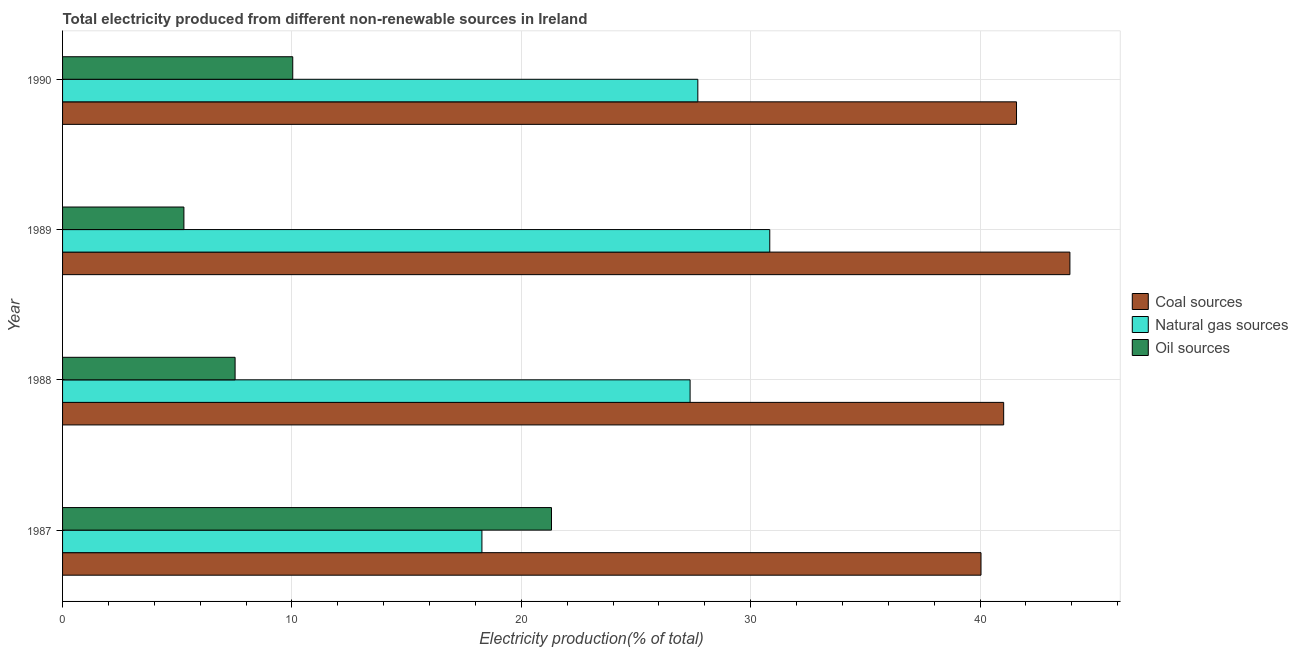How many different coloured bars are there?
Provide a short and direct response. 3. Are the number of bars per tick equal to the number of legend labels?
Your answer should be compact. Yes. How many bars are there on the 4th tick from the top?
Your answer should be very brief. 3. What is the label of the 2nd group of bars from the top?
Your response must be concise. 1989. In how many cases, is the number of bars for a given year not equal to the number of legend labels?
Offer a terse response. 0. What is the percentage of electricity produced by oil sources in 1990?
Your answer should be compact. 10.04. Across all years, what is the maximum percentage of electricity produced by oil sources?
Make the answer very short. 21.32. Across all years, what is the minimum percentage of electricity produced by coal?
Give a very brief answer. 40.04. In which year was the percentage of electricity produced by coal minimum?
Provide a short and direct response. 1987. What is the total percentage of electricity produced by oil sources in the graph?
Provide a succinct answer. 44.16. What is the difference between the percentage of electricity produced by oil sources in 1989 and that in 1990?
Your answer should be compact. -4.75. What is the difference between the percentage of electricity produced by coal in 1988 and the percentage of electricity produced by natural gas in 1987?
Provide a succinct answer. 22.75. What is the average percentage of electricity produced by coal per year?
Ensure brevity in your answer.  41.65. In the year 1988, what is the difference between the percentage of electricity produced by coal and percentage of electricity produced by natural gas?
Your answer should be very brief. 13.67. What is the ratio of the percentage of electricity produced by oil sources in 1987 to that in 1989?
Ensure brevity in your answer.  4.03. What is the difference between the highest and the second highest percentage of electricity produced by oil sources?
Give a very brief answer. 11.28. What is the difference between the highest and the lowest percentage of electricity produced by natural gas?
Offer a terse response. 12.55. In how many years, is the percentage of electricity produced by coal greater than the average percentage of electricity produced by coal taken over all years?
Offer a terse response. 1. What does the 3rd bar from the top in 1989 represents?
Give a very brief answer. Coal sources. What does the 2nd bar from the bottom in 1987 represents?
Your response must be concise. Natural gas sources. Is it the case that in every year, the sum of the percentage of electricity produced by coal and percentage of electricity produced by natural gas is greater than the percentage of electricity produced by oil sources?
Ensure brevity in your answer.  Yes. How many bars are there?
Offer a very short reply. 12. Are all the bars in the graph horizontal?
Keep it short and to the point. Yes. Are the values on the major ticks of X-axis written in scientific E-notation?
Offer a terse response. No. Where does the legend appear in the graph?
Your response must be concise. Center right. How many legend labels are there?
Offer a very short reply. 3. What is the title of the graph?
Keep it short and to the point. Total electricity produced from different non-renewable sources in Ireland. Does "Private sector" appear as one of the legend labels in the graph?
Provide a short and direct response. No. What is the label or title of the Y-axis?
Your response must be concise. Year. What is the Electricity production(% of total) of Coal sources in 1987?
Provide a succinct answer. 40.04. What is the Electricity production(% of total) of Natural gas sources in 1987?
Give a very brief answer. 18.28. What is the Electricity production(% of total) in Oil sources in 1987?
Your answer should be compact. 21.32. What is the Electricity production(% of total) in Coal sources in 1988?
Your answer should be compact. 41.03. What is the Electricity production(% of total) of Natural gas sources in 1988?
Your response must be concise. 27.36. What is the Electricity production(% of total) of Oil sources in 1988?
Provide a short and direct response. 7.52. What is the Electricity production(% of total) of Coal sources in 1989?
Provide a succinct answer. 43.92. What is the Electricity production(% of total) in Natural gas sources in 1989?
Your answer should be very brief. 30.83. What is the Electricity production(% of total) in Oil sources in 1989?
Ensure brevity in your answer.  5.29. What is the Electricity production(% of total) of Coal sources in 1990?
Make the answer very short. 41.59. What is the Electricity production(% of total) in Natural gas sources in 1990?
Offer a very short reply. 27.7. What is the Electricity production(% of total) of Oil sources in 1990?
Ensure brevity in your answer.  10.04. Across all years, what is the maximum Electricity production(% of total) of Coal sources?
Offer a terse response. 43.92. Across all years, what is the maximum Electricity production(% of total) in Natural gas sources?
Offer a terse response. 30.83. Across all years, what is the maximum Electricity production(% of total) of Oil sources?
Your answer should be compact. 21.32. Across all years, what is the minimum Electricity production(% of total) of Coal sources?
Make the answer very short. 40.04. Across all years, what is the minimum Electricity production(% of total) in Natural gas sources?
Ensure brevity in your answer.  18.28. Across all years, what is the minimum Electricity production(% of total) of Oil sources?
Your answer should be compact. 5.29. What is the total Electricity production(% of total) of Coal sources in the graph?
Offer a terse response. 166.58. What is the total Electricity production(% of total) in Natural gas sources in the graph?
Ensure brevity in your answer.  104.17. What is the total Electricity production(% of total) in Oil sources in the graph?
Your answer should be very brief. 44.16. What is the difference between the Electricity production(% of total) of Coal sources in 1987 and that in 1988?
Keep it short and to the point. -0.99. What is the difference between the Electricity production(% of total) in Natural gas sources in 1987 and that in 1988?
Ensure brevity in your answer.  -9.08. What is the difference between the Electricity production(% of total) in Oil sources in 1987 and that in 1988?
Provide a succinct answer. 13.79. What is the difference between the Electricity production(% of total) in Coal sources in 1987 and that in 1989?
Keep it short and to the point. -3.88. What is the difference between the Electricity production(% of total) of Natural gas sources in 1987 and that in 1989?
Your response must be concise. -12.55. What is the difference between the Electricity production(% of total) in Oil sources in 1987 and that in 1989?
Make the answer very short. 16.03. What is the difference between the Electricity production(% of total) of Coal sources in 1987 and that in 1990?
Keep it short and to the point. -1.55. What is the difference between the Electricity production(% of total) in Natural gas sources in 1987 and that in 1990?
Give a very brief answer. -9.41. What is the difference between the Electricity production(% of total) of Oil sources in 1987 and that in 1990?
Keep it short and to the point. 11.28. What is the difference between the Electricity production(% of total) of Coal sources in 1988 and that in 1989?
Give a very brief answer. -2.89. What is the difference between the Electricity production(% of total) in Natural gas sources in 1988 and that in 1989?
Keep it short and to the point. -3.47. What is the difference between the Electricity production(% of total) in Oil sources in 1988 and that in 1989?
Your response must be concise. 2.23. What is the difference between the Electricity production(% of total) of Coal sources in 1988 and that in 1990?
Ensure brevity in your answer.  -0.56. What is the difference between the Electricity production(% of total) of Natural gas sources in 1988 and that in 1990?
Give a very brief answer. -0.34. What is the difference between the Electricity production(% of total) of Oil sources in 1988 and that in 1990?
Provide a short and direct response. -2.51. What is the difference between the Electricity production(% of total) of Coal sources in 1989 and that in 1990?
Offer a very short reply. 2.33. What is the difference between the Electricity production(% of total) of Natural gas sources in 1989 and that in 1990?
Offer a very short reply. 3.14. What is the difference between the Electricity production(% of total) in Oil sources in 1989 and that in 1990?
Your answer should be very brief. -4.75. What is the difference between the Electricity production(% of total) in Coal sources in 1987 and the Electricity production(% of total) in Natural gas sources in 1988?
Your response must be concise. 12.68. What is the difference between the Electricity production(% of total) of Coal sources in 1987 and the Electricity production(% of total) of Oil sources in 1988?
Offer a very short reply. 32.52. What is the difference between the Electricity production(% of total) of Natural gas sources in 1987 and the Electricity production(% of total) of Oil sources in 1988?
Give a very brief answer. 10.76. What is the difference between the Electricity production(% of total) of Coal sources in 1987 and the Electricity production(% of total) of Natural gas sources in 1989?
Offer a very short reply. 9.21. What is the difference between the Electricity production(% of total) of Coal sources in 1987 and the Electricity production(% of total) of Oil sources in 1989?
Keep it short and to the point. 34.75. What is the difference between the Electricity production(% of total) in Natural gas sources in 1987 and the Electricity production(% of total) in Oil sources in 1989?
Keep it short and to the point. 12.99. What is the difference between the Electricity production(% of total) in Coal sources in 1987 and the Electricity production(% of total) in Natural gas sources in 1990?
Provide a succinct answer. 12.35. What is the difference between the Electricity production(% of total) of Coal sources in 1987 and the Electricity production(% of total) of Oil sources in 1990?
Give a very brief answer. 30.01. What is the difference between the Electricity production(% of total) of Natural gas sources in 1987 and the Electricity production(% of total) of Oil sources in 1990?
Offer a very short reply. 8.25. What is the difference between the Electricity production(% of total) of Coal sources in 1988 and the Electricity production(% of total) of Natural gas sources in 1989?
Offer a terse response. 10.2. What is the difference between the Electricity production(% of total) of Coal sources in 1988 and the Electricity production(% of total) of Oil sources in 1989?
Offer a terse response. 35.74. What is the difference between the Electricity production(% of total) in Natural gas sources in 1988 and the Electricity production(% of total) in Oil sources in 1989?
Provide a succinct answer. 22.07. What is the difference between the Electricity production(% of total) in Coal sources in 1988 and the Electricity production(% of total) in Natural gas sources in 1990?
Offer a terse response. 13.33. What is the difference between the Electricity production(% of total) of Coal sources in 1988 and the Electricity production(% of total) of Oil sources in 1990?
Provide a succinct answer. 31. What is the difference between the Electricity production(% of total) of Natural gas sources in 1988 and the Electricity production(% of total) of Oil sources in 1990?
Your answer should be compact. 17.32. What is the difference between the Electricity production(% of total) of Coal sources in 1989 and the Electricity production(% of total) of Natural gas sources in 1990?
Make the answer very short. 16.22. What is the difference between the Electricity production(% of total) in Coal sources in 1989 and the Electricity production(% of total) in Oil sources in 1990?
Provide a succinct answer. 33.88. What is the difference between the Electricity production(% of total) in Natural gas sources in 1989 and the Electricity production(% of total) in Oil sources in 1990?
Make the answer very short. 20.8. What is the average Electricity production(% of total) of Coal sources per year?
Ensure brevity in your answer.  41.65. What is the average Electricity production(% of total) in Natural gas sources per year?
Give a very brief answer. 26.04. What is the average Electricity production(% of total) in Oil sources per year?
Make the answer very short. 11.04. In the year 1987, what is the difference between the Electricity production(% of total) in Coal sources and Electricity production(% of total) in Natural gas sources?
Your response must be concise. 21.76. In the year 1987, what is the difference between the Electricity production(% of total) in Coal sources and Electricity production(% of total) in Oil sources?
Your response must be concise. 18.73. In the year 1987, what is the difference between the Electricity production(% of total) of Natural gas sources and Electricity production(% of total) of Oil sources?
Your answer should be compact. -3.03. In the year 1988, what is the difference between the Electricity production(% of total) in Coal sources and Electricity production(% of total) in Natural gas sources?
Offer a very short reply. 13.67. In the year 1988, what is the difference between the Electricity production(% of total) in Coal sources and Electricity production(% of total) in Oil sources?
Offer a terse response. 33.51. In the year 1988, what is the difference between the Electricity production(% of total) of Natural gas sources and Electricity production(% of total) of Oil sources?
Ensure brevity in your answer.  19.84. In the year 1989, what is the difference between the Electricity production(% of total) of Coal sources and Electricity production(% of total) of Natural gas sources?
Make the answer very short. 13.09. In the year 1989, what is the difference between the Electricity production(% of total) of Coal sources and Electricity production(% of total) of Oil sources?
Your answer should be very brief. 38.63. In the year 1989, what is the difference between the Electricity production(% of total) in Natural gas sources and Electricity production(% of total) in Oil sources?
Offer a very short reply. 25.54. In the year 1990, what is the difference between the Electricity production(% of total) of Coal sources and Electricity production(% of total) of Natural gas sources?
Your answer should be very brief. 13.89. In the year 1990, what is the difference between the Electricity production(% of total) in Coal sources and Electricity production(% of total) in Oil sources?
Your answer should be compact. 31.56. In the year 1990, what is the difference between the Electricity production(% of total) in Natural gas sources and Electricity production(% of total) in Oil sources?
Offer a very short reply. 17.66. What is the ratio of the Electricity production(% of total) of Coal sources in 1987 to that in 1988?
Make the answer very short. 0.98. What is the ratio of the Electricity production(% of total) of Natural gas sources in 1987 to that in 1988?
Your answer should be compact. 0.67. What is the ratio of the Electricity production(% of total) in Oil sources in 1987 to that in 1988?
Your answer should be compact. 2.83. What is the ratio of the Electricity production(% of total) in Coal sources in 1987 to that in 1989?
Provide a succinct answer. 0.91. What is the ratio of the Electricity production(% of total) in Natural gas sources in 1987 to that in 1989?
Provide a short and direct response. 0.59. What is the ratio of the Electricity production(% of total) in Oil sources in 1987 to that in 1989?
Make the answer very short. 4.03. What is the ratio of the Electricity production(% of total) of Coal sources in 1987 to that in 1990?
Give a very brief answer. 0.96. What is the ratio of the Electricity production(% of total) in Natural gas sources in 1987 to that in 1990?
Provide a succinct answer. 0.66. What is the ratio of the Electricity production(% of total) of Oil sources in 1987 to that in 1990?
Keep it short and to the point. 2.12. What is the ratio of the Electricity production(% of total) in Coal sources in 1988 to that in 1989?
Provide a succinct answer. 0.93. What is the ratio of the Electricity production(% of total) of Natural gas sources in 1988 to that in 1989?
Make the answer very short. 0.89. What is the ratio of the Electricity production(% of total) in Oil sources in 1988 to that in 1989?
Provide a succinct answer. 1.42. What is the ratio of the Electricity production(% of total) of Coal sources in 1988 to that in 1990?
Your answer should be compact. 0.99. What is the ratio of the Electricity production(% of total) of Oil sources in 1988 to that in 1990?
Make the answer very short. 0.75. What is the ratio of the Electricity production(% of total) of Coal sources in 1989 to that in 1990?
Make the answer very short. 1.06. What is the ratio of the Electricity production(% of total) of Natural gas sources in 1989 to that in 1990?
Provide a short and direct response. 1.11. What is the ratio of the Electricity production(% of total) of Oil sources in 1989 to that in 1990?
Provide a succinct answer. 0.53. What is the difference between the highest and the second highest Electricity production(% of total) in Coal sources?
Provide a succinct answer. 2.33. What is the difference between the highest and the second highest Electricity production(% of total) of Natural gas sources?
Offer a terse response. 3.14. What is the difference between the highest and the second highest Electricity production(% of total) of Oil sources?
Make the answer very short. 11.28. What is the difference between the highest and the lowest Electricity production(% of total) of Coal sources?
Your response must be concise. 3.88. What is the difference between the highest and the lowest Electricity production(% of total) of Natural gas sources?
Your answer should be compact. 12.55. What is the difference between the highest and the lowest Electricity production(% of total) of Oil sources?
Provide a succinct answer. 16.03. 